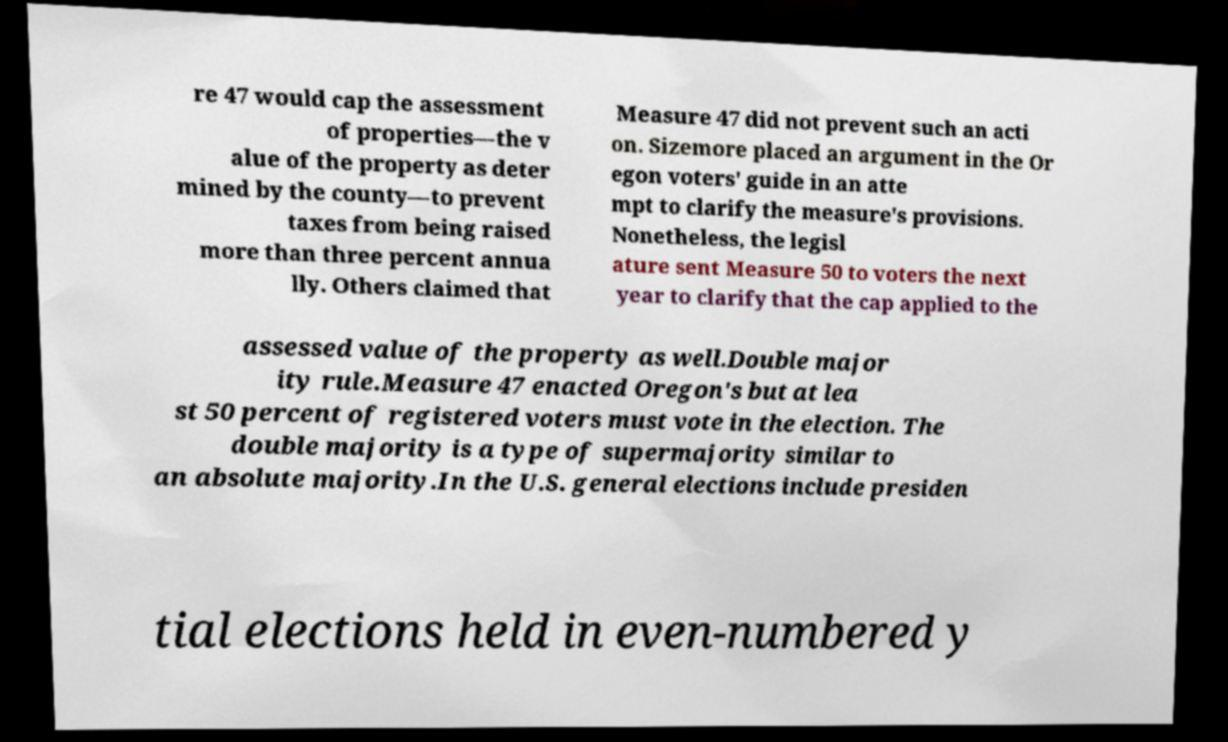Please identify and transcribe the text found in this image. re 47 would cap the assessment of properties—the v alue of the property as deter mined by the county—to prevent taxes from being raised more than three percent annua lly. Others claimed that Measure 47 did not prevent such an acti on. Sizemore placed an argument in the Or egon voters' guide in an atte mpt to clarify the measure's provisions. Nonetheless, the legisl ature sent Measure 50 to voters the next year to clarify that the cap applied to the assessed value of the property as well.Double major ity rule.Measure 47 enacted Oregon's but at lea st 50 percent of registered voters must vote in the election. The double majority is a type of supermajority similar to an absolute majority.In the U.S. general elections include presiden tial elections held in even-numbered y 